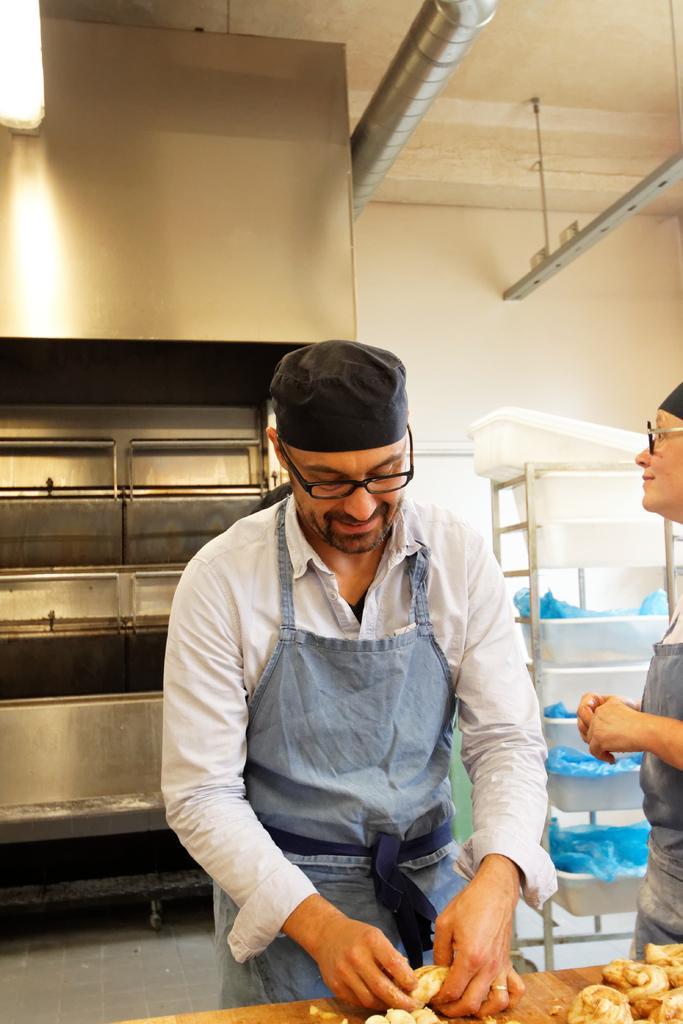How would you summarize this image in a sentence or two? In this image there are two people who are doing something, at the bottom there is a table. On the table there are some objects, and in the background there are cupboards and some baskets and there is a wall. At the top there is a pipe, ceiling and rod. 